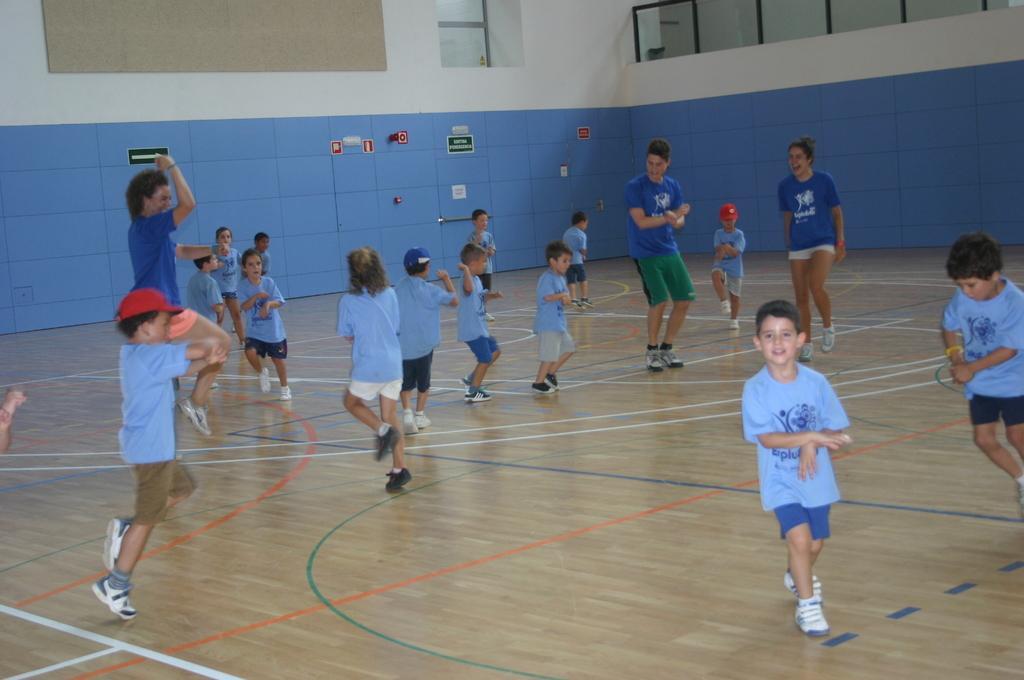Can you describe this image briefly? In this image few kids are dancing on the floor. Three persons wearing blue shirts are dancing. Background there is a wall having windows. A kid wearing a blue shirt is dancing at the left side of image. He is wearing red color cap. 